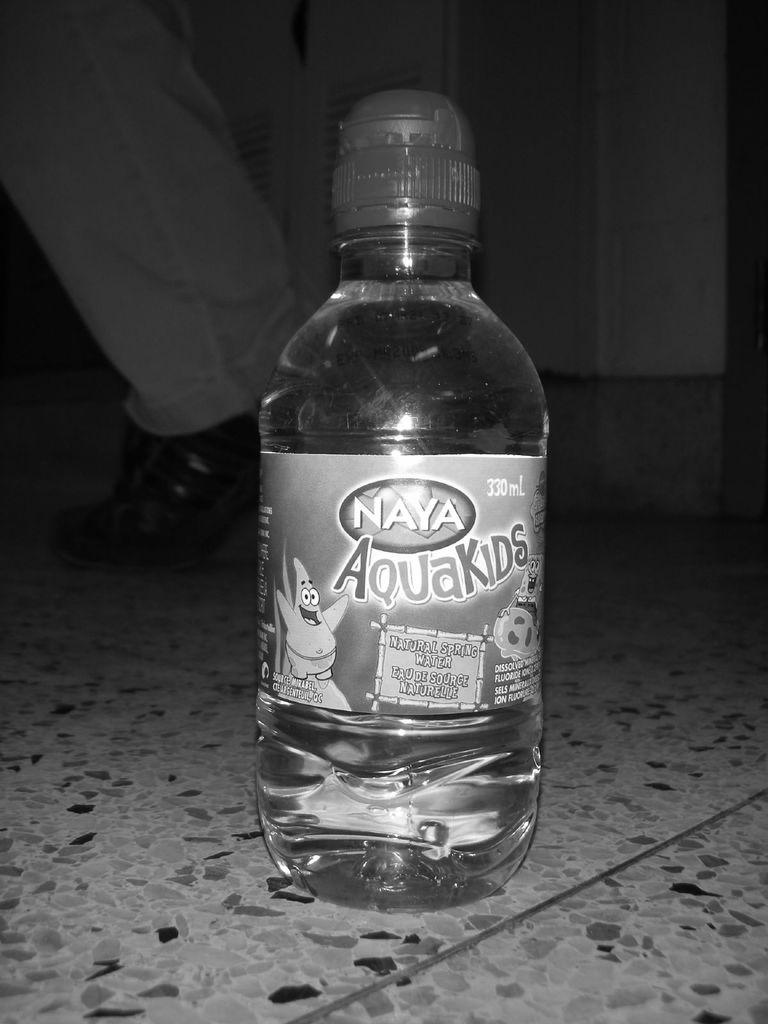<image>
Provide a brief description of the given image. Naya Aquakids water using cartoon characters on their packaging. 